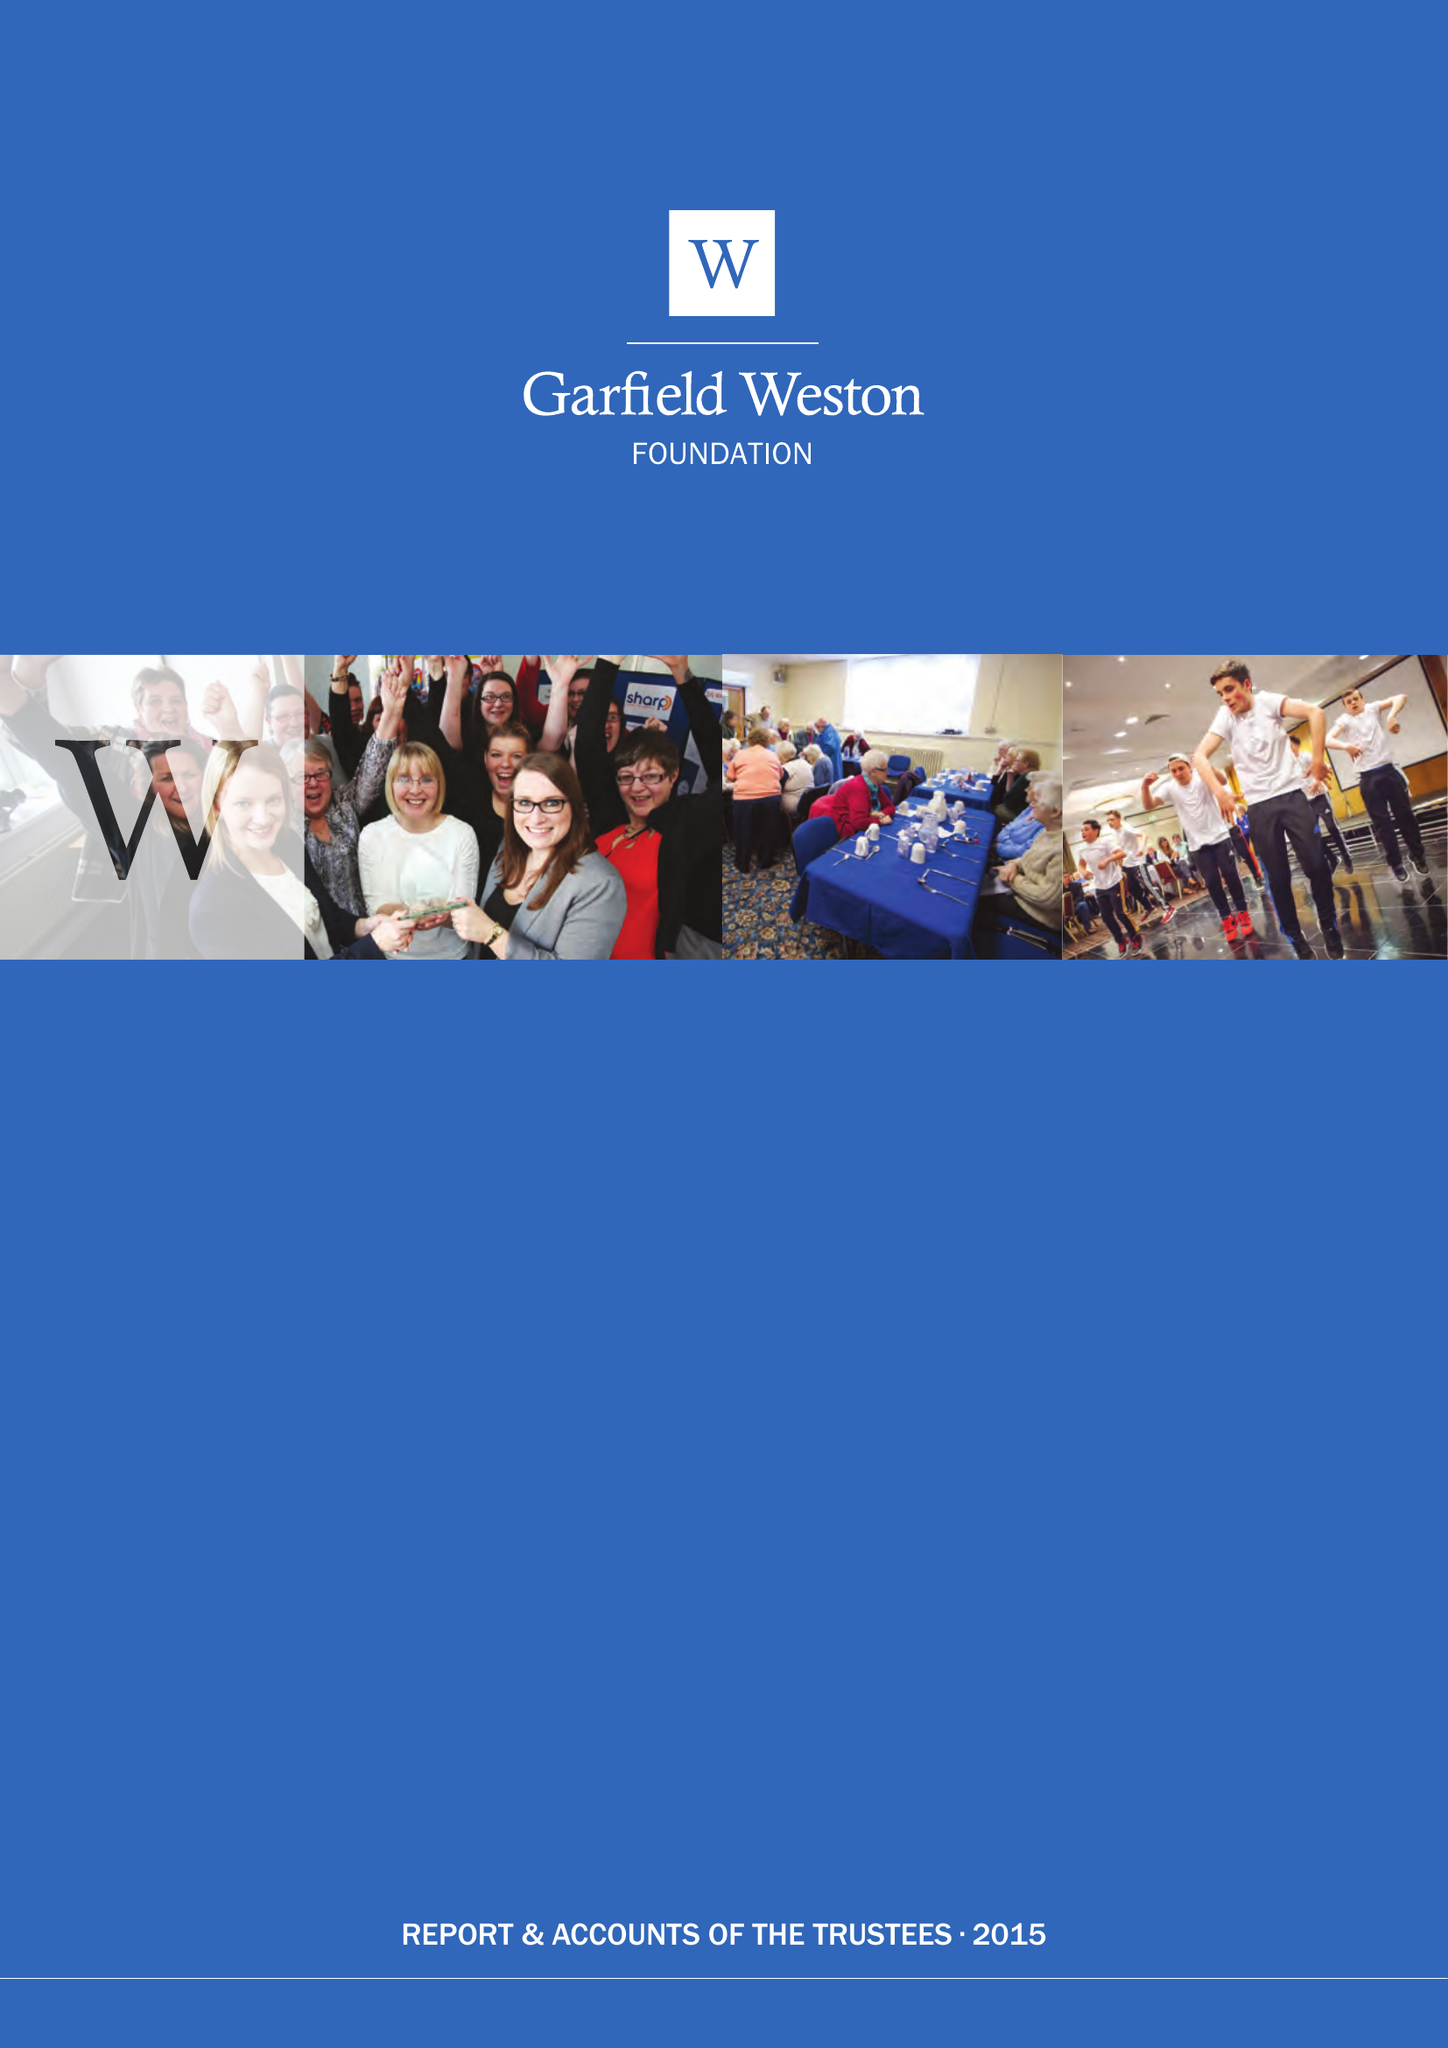What is the value for the report_date?
Answer the question using a single word or phrase. 2015-04-05 